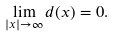Convert formula to latex. <formula><loc_0><loc_0><loc_500><loc_500>\lim _ { | x | \to \infty } d ( x ) = 0 .</formula> 